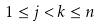<formula> <loc_0><loc_0><loc_500><loc_500>1 \leq j < k \leq n</formula> 